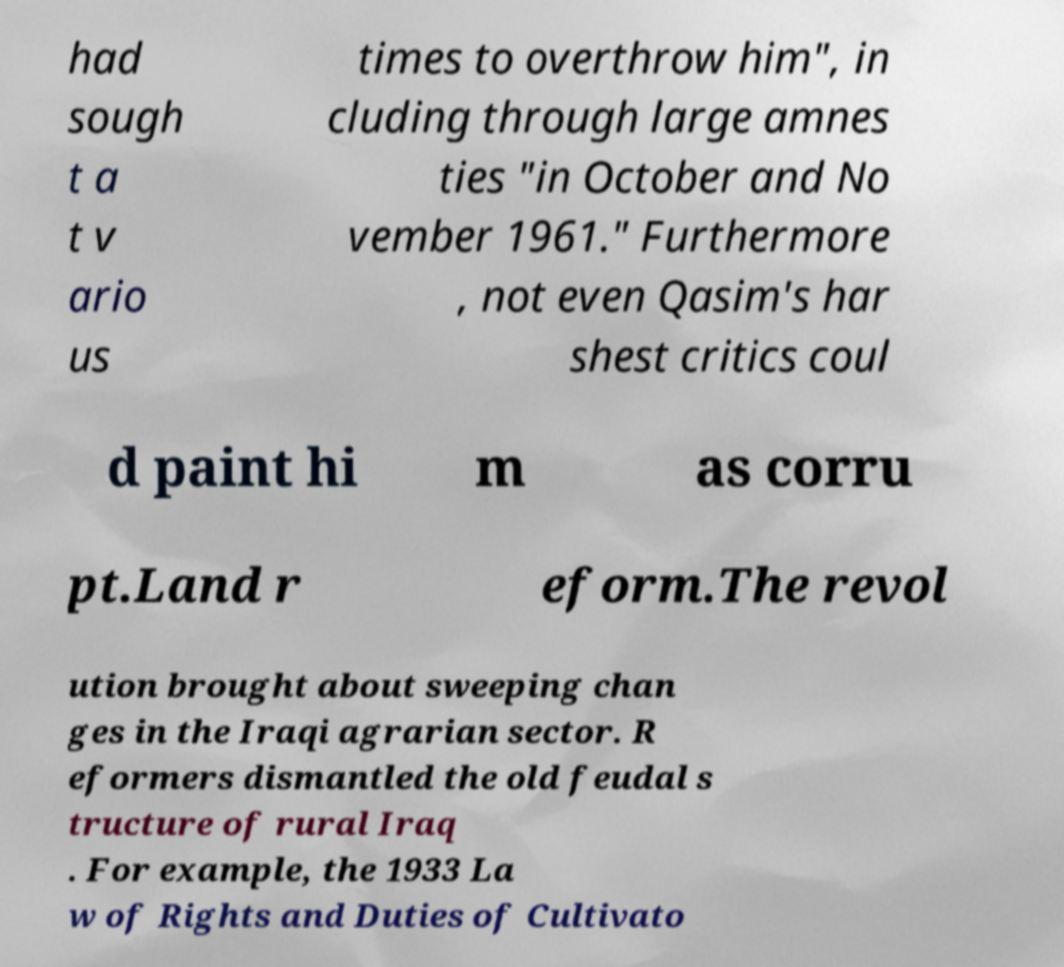What messages or text are displayed in this image? I need them in a readable, typed format. had sough t a t v ario us times to overthrow him", in cluding through large amnes ties "in October and No vember 1961." Furthermore , not even Qasim's har shest critics coul d paint hi m as corru pt.Land r eform.The revol ution brought about sweeping chan ges in the Iraqi agrarian sector. R eformers dismantled the old feudal s tructure of rural Iraq . For example, the 1933 La w of Rights and Duties of Cultivato 